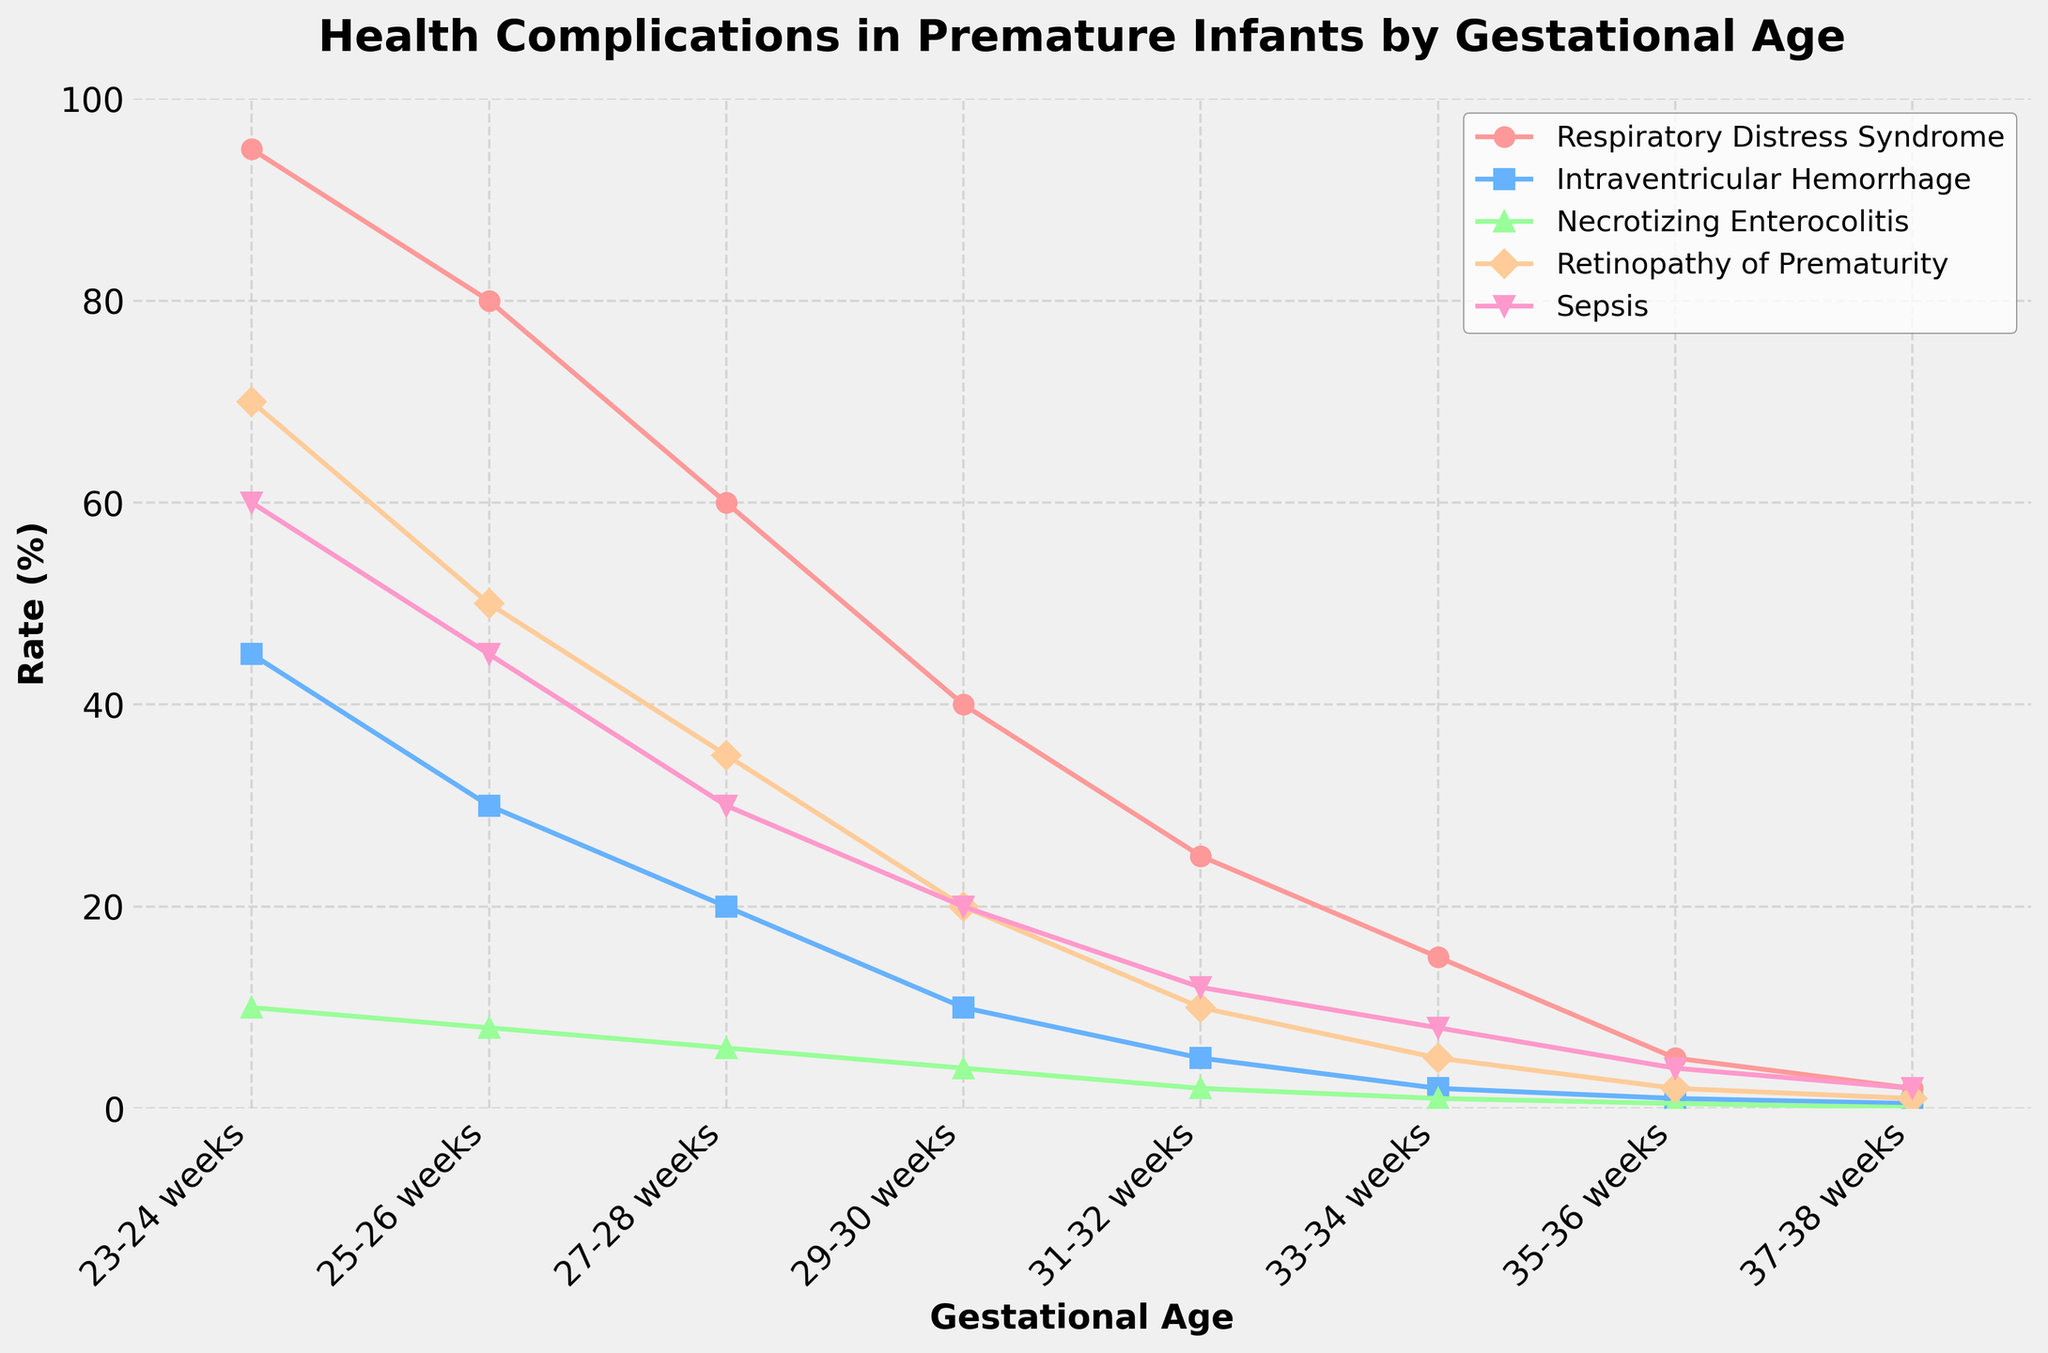What is the gestational age range with the highest incidence of Respiratory Distress Syndrome? The height of the red line representing Respiratory Distress Syndrome is highest at 23-24 weeks. This indicates that the incidence is the highest in this range.
Answer: 23-24 weeks Which health complication has the sharpest decline as gestational age increases? The lines representing each health complication can be observed. The pink line for Respiratory Distress Syndrome shows the sharpest decline from 95% at 23-24 weeks to 2% at 37-38 weeks.
Answer: Respiratory Distress Syndrome What is the combined rate of Intraventricular Hemorrhage and Sepsis at 31-32 weeks? At 31-32 weeks, locate the points for Intraventricular Hemorrhage (5%) and Sepsis (12%). Adding them gives a combined rate: 5% + 12% = 17%.
Answer: 17% Which health complication is represented by the green line, and what is its rate at 27-28 weeks? Follow the green line and note that it corresponds to Necrotizing Enterocolitis, which has a rate of 6% at 27-28 weeks.
Answer: Necrotizing Enterocolitis, 6% Comparing the rates of Sepsis at 33-34 weeks and 35-36 weeks, which one is higher, and by how much? Locate the points for Sepsis at 33-34 weeks (8%) and 35-36 weeks (4%). The rate at 33-34 weeks is higher by 8% - 4% = 4%.
Answer: 33-34 weeks, by 4% What is the average rate of Retinopathy of Prematurity across all gestational ages? Sum the rates of Retinopathy of Prematurity at all gestational ages: 70% + 50% + 35% + 20% + 10% + 5% + 2% + 1% = 193%. Divide by 8 (number of gestational age groups): 193%/8 = 24.125%.
Answer: 24.125% At which gestational age does Intraventricular Hemorrhage drop below 10%? Follow the blue line for Intraventricular Hemorrhage and find the point where it first drops below 10%, which occurs at 29-30 weeks (10%).
Answer: 31-32 weeks Which health complication has the least variation in its rates across the gestational ages? Observe the lines representing each health complication. The purple line for Retinopathy of Prematurity shows the least variation across the ages, fluctuating between 70% and 1%.
Answer: Retinopathy of Prematurity 